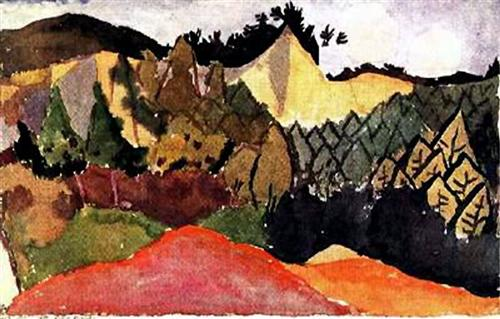Can you identify any specific techniques the artist used? The artist has employed broad, confident brushstrokes that contribute to the painting's lively texture. The use of contrasting colors next to each other without blending suggests a technique reminiscent of pointillism but executed with more gestural freedom. This method allows for dynamic movement and a three-dimensional quality within the flat image. What emotions might this painting evoke in a viewer? The intense colors and bold composition may evoke feelings of awe and joy. The painting's abstraction allows for a personal interpretation, where viewers might find themselves inspired or soothed by the landscape, possibly stirring a sense of adventure or nostalgia for the natural world. 